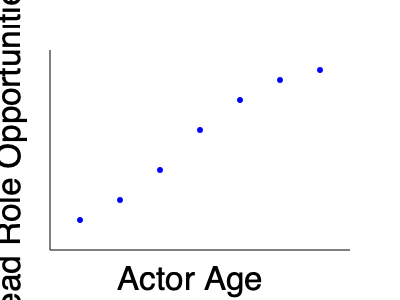As an aspiring actor dreaming of stardom, you're analyzing the relationship between actor age and lead role opportunities. Based on the scatter plot, what type of correlation exists between these variables, and how might this impact your career strategy? To answer this question, let's analyze the scatter plot step-by-step:

1. Observe the overall trend: As we move from left to right (increasing age), the points generally move downward (decreasing lead role opportunities).

2. Identify the correlation type: This downward trend indicates a negative correlation between actor age and lead role opportunities.

3. Assess the strength of the correlation: The points follow a fairly consistent downward pattern without much scatter, suggesting a strong negative correlation.

4. Interpret the correlation:
   a) Younger actors (left side of the plot) tend to have more lead role opportunities.
   b) As actors age (moving right on the plot), their lead role opportunities decrease.

5. Consider the implications for your career strategy:
   a) Capitalize on youth: Pursue lead roles aggressively while you're young.
   b) Diversify skills: As you age, develop versatility to adapt to changing opportunities.
   c) Build a strong reputation: Establish yourself early to maintain relevance as you age.
   d) Consider character roles: Be open to transitioning to supporting roles as you get older.

6. Remember outliers: While the trend is clear, individual experiences may vary. Some older actors continue to secure lead roles due to talent, reputation, or niche appeal.
Answer: Strong negative correlation; prioritize early career opportunities while developing versatility for long-term success. 